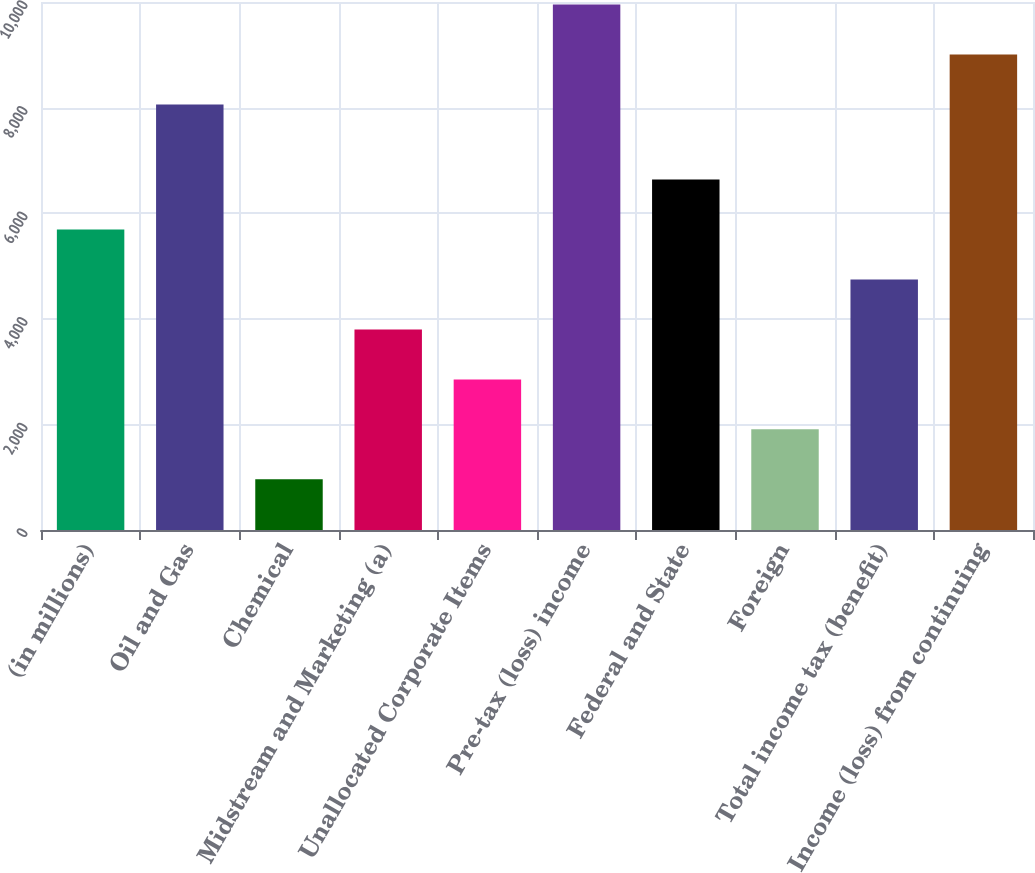Convert chart to OTSL. <chart><loc_0><loc_0><loc_500><loc_500><bar_chart><fcel>(in millions)<fcel>Oil and Gas<fcel>Chemical<fcel>Midstream and Marketing (a)<fcel>Unallocated Corporate Items<fcel>Pre-tax (loss) income<fcel>Federal and State<fcel>Foreign<fcel>Total income tax (benefit)<fcel>Income (loss) from continuing<nl><fcel>5691.2<fcel>8060<fcel>960.2<fcel>3798.8<fcel>2852.6<fcel>9952.4<fcel>6637.4<fcel>1906.4<fcel>4745<fcel>9006.2<nl></chart> 